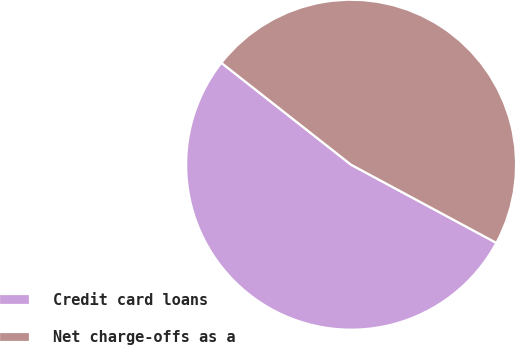Convert chart. <chart><loc_0><loc_0><loc_500><loc_500><pie_chart><fcel>Credit card loans<fcel>Net charge-offs as a<nl><fcel>52.74%<fcel>47.26%<nl></chart> 